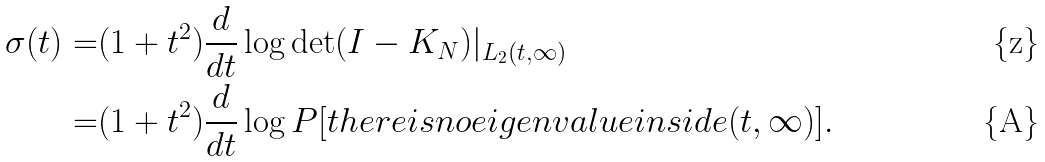<formula> <loc_0><loc_0><loc_500><loc_500>\sigma ( t ) = & ( 1 + t ^ { 2 } ) \frac { d } { d t } \log \det ( I - K _ { N } ) | _ { L _ { 2 } ( t , \infty ) } \\ = & ( 1 + t ^ { 2 } ) \frac { d } { d t } \log P [ t h e r e i s n o e i g e n v a l u e i n s i d e ( t , \infty ) ] .</formula> 